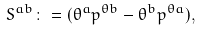Convert formula to latex. <formula><loc_0><loc_0><loc_500><loc_500>S ^ { a b } \colon = ( \theta ^ { a } p ^ { \theta b } - \theta ^ { b } p ^ { \theta a } ) ,</formula> 